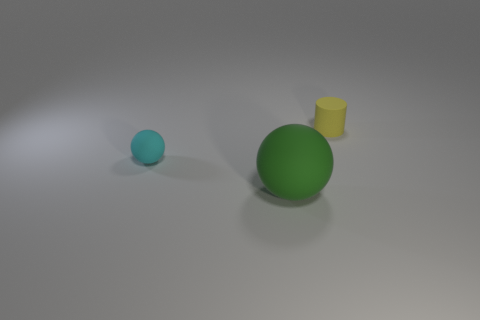Is there anything about the arrangement of these objects that suggests a particular theme or purpose? The arrangement of objects appears random, with varying sizes and spacing, which does not suggest any intentional theme or specific purpose beyond a possible visual study of geometry and color. 